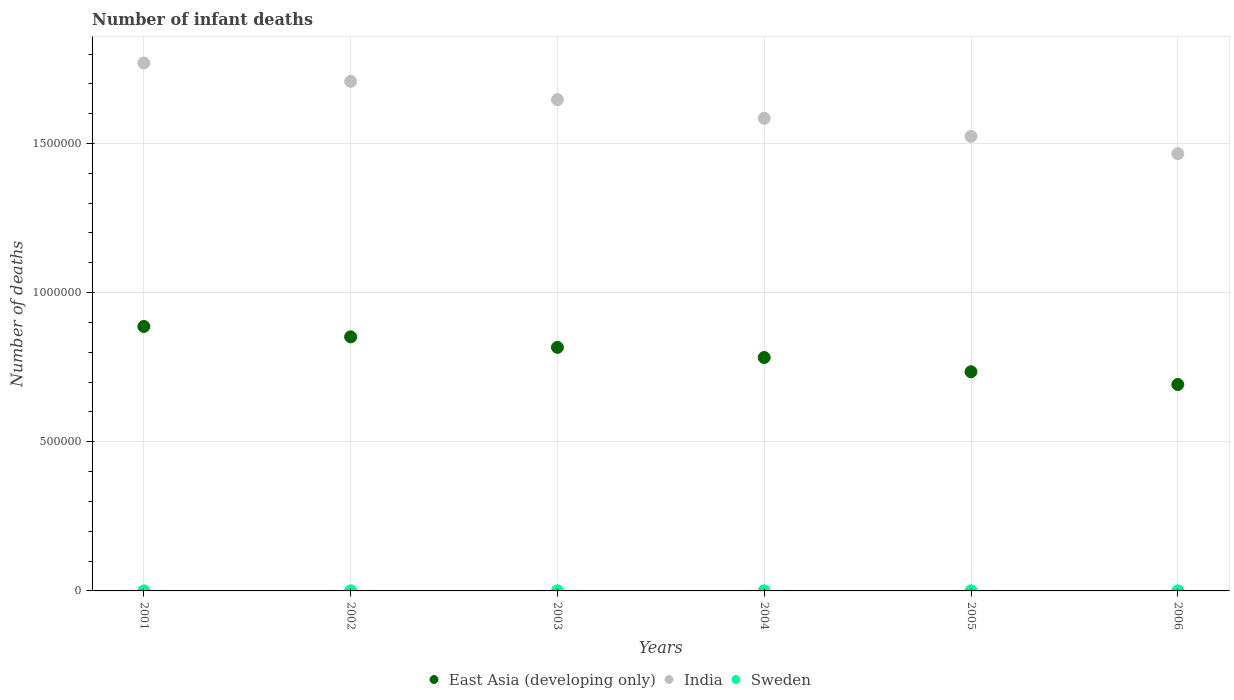How many different coloured dotlines are there?
Make the answer very short. 3. Is the number of dotlines equal to the number of legend labels?
Provide a short and direct response. Yes. What is the number of infant deaths in Sweden in 2005?
Your response must be concise. 351. Across all years, what is the maximum number of infant deaths in India?
Make the answer very short. 1.77e+06. Across all years, what is the minimum number of infant deaths in India?
Offer a terse response. 1.47e+06. In which year was the number of infant deaths in East Asia (developing only) maximum?
Your response must be concise. 2001. In which year was the number of infant deaths in Sweden minimum?
Your answer should be very brief. 2001. What is the total number of infant deaths in Sweden in the graph?
Make the answer very short. 1871. What is the difference between the number of infant deaths in Sweden in 2001 and that in 2004?
Keep it short and to the point. -83. What is the difference between the number of infant deaths in Sweden in 2005 and the number of infant deaths in East Asia (developing only) in 2001?
Your answer should be compact. -8.86e+05. What is the average number of infant deaths in East Asia (developing only) per year?
Your response must be concise. 7.94e+05. In the year 2003, what is the difference between the number of infant deaths in Sweden and number of infant deaths in East Asia (developing only)?
Keep it short and to the point. -8.16e+05. In how many years, is the number of infant deaths in India greater than 700000?
Ensure brevity in your answer.  6. What is the ratio of the number of infant deaths in Sweden in 2003 to that in 2005?
Your response must be concise. 0.89. Is the number of infant deaths in Sweden in 2002 less than that in 2006?
Give a very brief answer. Yes. What is the difference between the highest and the second highest number of infant deaths in Sweden?
Your answer should be very brief. 13. What is the difference between the highest and the lowest number of infant deaths in India?
Give a very brief answer. 3.04e+05. Is the sum of the number of infant deaths in India in 2003 and 2006 greater than the maximum number of infant deaths in Sweden across all years?
Your answer should be very brief. Yes. Does the number of infant deaths in Sweden monotonically increase over the years?
Your answer should be very brief. No. How many dotlines are there?
Provide a short and direct response. 3. Are the values on the major ticks of Y-axis written in scientific E-notation?
Make the answer very short. No. Does the graph contain any zero values?
Provide a succinct answer. No. Does the graph contain grids?
Your answer should be compact. Yes. How many legend labels are there?
Ensure brevity in your answer.  3. How are the legend labels stacked?
Your response must be concise. Horizontal. What is the title of the graph?
Provide a short and direct response. Number of infant deaths. Does "Comoros" appear as one of the legend labels in the graph?
Provide a short and direct response. No. What is the label or title of the Y-axis?
Provide a succinct answer. Number of deaths. What is the Number of deaths of East Asia (developing only) in 2001?
Your answer should be compact. 8.87e+05. What is the Number of deaths in India in 2001?
Your answer should be very brief. 1.77e+06. What is the Number of deaths of Sweden in 2001?
Your response must be concise. 255. What is the Number of deaths in East Asia (developing only) in 2002?
Provide a short and direct response. 8.52e+05. What is the Number of deaths of India in 2002?
Offer a terse response. 1.71e+06. What is the Number of deaths of Sweden in 2002?
Offer a very short reply. 280. What is the Number of deaths in East Asia (developing only) in 2003?
Keep it short and to the point. 8.16e+05. What is the Number of deaths of India in 2003?
Provide a short and direct response. 1.65e+06. What is the Number of deaths in Sweden in 2003?
Your answer should be compact. 311. What is the Number of deaths in East Asia (developing only) in 2004?
Make the answer very short. 7.83e+05. What is the Number of deaths in India in 2004?
Offer a terse response. 1.58e+06. What is the Number of deaths of Sweden in 2004?
Your answer should be very brief. 338. What is the Number of deaths in East Asia (developing only) in 2005?
Ensure brevity in your answer.  7.35e+05. What is the Number of deaths of India in 2005?
Your response must be concise. 1.52e+06. What is the Number of deaths in Sweden in 2005?
Provide a succinct answer. 351. What is the Number of deaths of East Asia (developing only) in 2006?
Your answer should be compact. 6.92e+05. What is the Number of deaths in India in 2006?
Ensure brevity in your answer.  1.47e+06. What is the Number of deaths in Sweden in 2006?
Keep it short and to the point. 336. Across all years, what is the maximum Number of deaths of East Asia (developing only)?
Your answer should be very brief. 8.87e+05. Across all years, what is the maximum Number of deaths of India?
Provide a succinct answer. 1.77e+06. Across all years, what is the maximum Number of deaths in Sweden?
Your answer should be compact. 351. Across all years, what is the minimum Number of deaths of East Asia (developing only)?
Provide a short and direct response. 6.92e+05. Across all years, what is the minimum Number of deaths of India?
Your response must be concise. 1.47e+06. Across all years, what is the minimum Number of deaths in Sweden?
Provide a succinct answer. 255. What is the total Number of deaths of East Asia (developing only) in the graph?
Keep it short and to the point. 4.76e+06. What is the total Number of deaths of India in the graph?
Make the answer very short. 9.70e+06. What is the total Number of deaths of Sweden in the graph?
Make the answer very short. 1871. What is the difference between the Number of deaths of East Asia (developing only) in 2001 and that in 2002?
Provide a short and direct response. 3.48e+04. What is the difference between the Number of deaths of India in 2001 and that in 2002?
Make the answer very short. 6.18e+04. What is the difference between the Number of deaths in Sweden in 2001 and that in 2002?
Provide a succinct answer. -25. What is the difference between the Number of deaths of East Asia (developing only) in 2001 and that in 2003?
Your response must be concise. 7.01e+04. What is the difference between the Number of deaths of India in 2001 and that in 2003?
Your answer should be very brief. 1.23e+05. What is the difference between the Number of deaths in Sweden in 2001 and that in 2003?
Make the answer very short. -56. What is the difference between the Number of deaths in East Asia (developing only) in 2001 and that in 2004?
Offer a very short reply. 1.04e+05. What is the difference between the Number of deaths of India in 2001 and that in 2004?
Your answer should be compact. 1.86e+05. What is the difference between the Number of deaths of Sweden in 2001 and that in 2004?
Your answer should be very brief. -83. What is the difference between the Number of deaths in East Asia (developing only) in 2001 and that in 2005?
Provide a short and direct response. 1.52e+05. What is the difference between the Number of deaths of India in 2001 and that in 2005?
Ensure brevity in your answer.  2.46e+05. What is the difference between the Number of deaths in Sweden in 2001 and that in 2005?
Your answer should be compact. -96. What is the difference between the Number of deaths in East Asia (developing only) in 2001 and that in 2006?
Offer a very short reply. 1.95e+05. What is the difference between the Number of deaths in India in 2001 and that in 2006?
Your answer should be compact. 3.04e+05. What is the difference between the Number of deaths of Sweden in 2001 and that in 2006?
Provide a short and direct response. -81. What is the difference between the Number of deaths of East Asia (developing only) in 2002 and that in 2003?
Provide a short and direct response. 3.53e+04. What is the difference between the Number of deaths in India in 2002 and that in 2003?
Provide a succinct answer. 6.11e+04. What is the difference between the Number of deaths in Sweden in 2002 and that in 2003?
Offer a very short reply. -31. What is the difference between the Number of deaths in East Asia (developing only) in 2002 and that in 2004?
Provide a short and direct response. 6.93e+04. What is the difference between the Number of deaths of India in 2002 and that in 2004?
Ensure brevity in your answer.  1.24e+05. What is the difference between the Number of deaths in Sweden in 2002 and that in 2004?
Provide a short and direct response. -58. What is the difference between the Number of deaths in East Asia (developing only) in 2002 and that in 2005?
Your answer should be compact. 1.17e+05. What is the difference between the Number of deaths of India in 2002 and that in 2005?
Your answer should be compact. 1.84e+05. What is the difference between the Number of deaths in Sweden in 2002 and that in 2005?
Offer a terse response. -71. What is the difference between the Number of deaths in East Asia (developing only) in 2002 and that in 2006?
Your answer should be very brief. 1.60e+05. What is the difference between the Number of deaths of India in 2002 and that in 2006?
Provide a short and direct response. 2.42e+05. What is the difference between the Number of deaths of Sweden in 2002 and that in 2006?
Make the answer very short. -56. What is the difference between the Number of deaths of East Asia (developing only) in 2003 and that in 2004?
Your answer should be very brief. 3.40e+04. What is the difference between the Number of deaths of India in 2003 and that in 2004?
Provide a succinct answer. 6.26e+04. What is the difference between the Number of deaths of Sweden in 2003 and that in 2004?
Make the answer very short. -27. What is the difference between the Number of deaths in East Asia (developing only) in 2003 and that in 2005?
Your answer should be very brief. 8.17e+04. What is the difference between the Number of deaths of India in 2003 and that in 2005?
Keep it short and to the point. 1.23e+05. What is the difference between the Number of deaths of Sweden in 2003 and that in 2005?
Make the answer very short. -40. What is the difference between the Number of deaths of East Asia (developing only) in 2003 and that in 2006?
Your answer should be very brief. 1.24e+05. What is the difference between the Number of deaths of India in 2003 and that in 2006?
Your response must be concise. 1.81e+05. What is the difference between the Number of deaths in East Asia (developing only) in 2004 and that in 2005?
Keep it short and to the point. 4.77e+04. What is the difference between the Number of deaths of India in 2004 and that in 2005?
Your response must be concise. 6.06e+04. What is the difference between the Number of deaths of Sweden in 2004 and that in 2005?
Give a very brief answer. -13. What is the difference between the Number of deaths in East Asia (developing only) in 2004 and that in 2006?
Your answer should be compact. 9.05e+04. What is the difference between the Number of deaths of India in 2004 and that in 2006?
Your response must be concise. 1.19e+05. What is the difference between the Number of deaths of Sweden in 2004 and that in 2006?
Your answer should be compact. 2. What is the difference between the Number of deaths of East Asia (developing only) in 2005 and that in 2006?
Your answer should be compact. 4.28e+04. What is the difference between the Number of deaths of India in 2005 and that in 2006?
Your response must be concise. 5.80e+04. What is the difference between the Number of deaths in Sweden in 2005 and that in 2006?
Ensure brevity in your answer.  15. What is the difference between the Number of deaths in East Asia (developing only) in 2001 and the Number of deaths in India in 2002?
Keep it short and to the point. -8.22e+05. What is the difference between the Number of deaths of East Asia (developing only) in 2001 and the Number of deaths of Sweden in 2002?
Ensure brevity in your answer.  8.86e+05. What is the difference between the Number of deaths in India in 2001 and the Number of deaths in Sweden in 2002?
Offer a terse response. 1.77e+06. What is the difference between the Number of deaths in East Asia (developing only) in 2001 and the Number of deaths in India in 2003?
Keep it short and to the point. -7.60e+05. What is the difference between the Number of deaths of East Asia (developing only) in 2001 and the Number of deaths of Sweden in 2003?
Offer a very short reply. 8.86e+05. What is the difference between the Number of deaths of India in 2001 and the Number of deaths of Sweden in 2003?
Offer a very short reply. 1.77e+06. What is the difference between the Number of deaths in East Asia (developing only) in 2001 and the Number of deaths in India in 2004?
Your answer should be very brief. -6.98e+05. What is the difference between the Number of deaths in East Asia (developing only) in 2001 and the Number of deaths in Sweden in 2004?
Offer a very short reply. 8.86e+05. What is the difference between the Number of deaths in India in 2001 and the Number of deaths in Sweden in 2004?
Your answer should be compact. 1.77e+06. What is the difference between the Number of deaths of East Asia (developing only) in 2001 and the Number of deaths of India in 2005?
Your answer should be very brief. -6.37e+05. What is the difference between the Number of deaths in East Asia (developing only) in 2001 and the Number of deaths in Sweden in 2005?
Your response must be concise. 8.86e+05. What is the difference between the Number of deaths in India in 2001 and the Number of deaths in Sweden in 2005?
Make the answer very short. 1.77e+06. What is the difference between the Number of deaths of East Asia (developing only) in 2001 and the Number of deaths of India in 2006?
Provide a short and direct response. -5.79e+05. What is the difference between the Number of deaths of East Asia (developing only) in 2001 and the Number of deaths of Sweden in 2006?
Provide a succinct answer. 8.86e+05. What is the difference between the Number of deaths in India in 2001 and the Number of deaths in Sweden in 2006?
Provide a short and direct response. 1.77e+06. What is the difference between the Number of deaths in East Asia (developing only) in 2002 and the Number of deaths in India in 2003?
Your answer should be compact. -7.95e+05. What is the difference between the Number of deaths of East Asia (developing only) in 2002 and the Number of deaths of Sweden in 2003?
Make the answer very short. 8.51e+05. What is the difference between the Number of deaths in India in 2002 and the Number of deaths in Sweden in 2003?
Make the answer very short. 1.71e+06. What is the difference between the Number of deaths of East Asia (developing only) in 2002 and the Number of deaths of India in 2004?
Your answer should be very brief. -7.33e+05. What is the difference between the Number of deaths in East Asia (developing only) in 2002 and the Number of deaths in Sweden in 2004?
Keep it short and to the point. 8.51e+05. What is the difference between the Number of deaths of India in 2002 and the Number of deaths of Sweden in 2004?
Your response must be concise. 1.71e+06. What is the difference between the Number of deaths of East Asia (developing only) in 2002 and the Number of deaths of India in 2005?
Provide a short and direct response. -6.72e+05. What is the difference between the Number of deaths in East Asia (developing only) in 2002 and the Number of deaths in Sweden in 2005?
Keep it short and to the point. 8.51e+05. What is the difference between the Number of deaths in India in 2002 and the Number of deaths in Sweden in 2005?
Provide a succinct answer. 1.71e+06. What is the difference between the Number of deaths in East Asia (developing only) in 2002 and the Number of deaths in India in 2006?
Make the answer very short. -6.14e+05. What is the difference between the Number of deaths in East Asia (developing only) in 2002 and the Number of deaths in Sweden in 2006?
Your response must be concise. 8.51e+05. What is the difference between the Number of deaths in India in 2002 and the Number of deaths in Sweden in 2006?
Offer a terse response. 1.71e+06. What is the difference between the Number of deaths of East Asia (developing only) in 2003 and the Number of deaths of India in 2004?
Make the answer very short. -7.68e+05. What is the difference between the Number of deaths in East Asia (developing only) in 2003 and the Number of deaths in Sweden in 2004?
Provide a succinct answer. 8.16e+05. What is the difference between the Number of deaths in India in 2003 and the Number of deaths in Sweden in 2004?
Offer a terse response. 1.65e+06. What is the difference between the Number of deaths of East Asia (developing only) in 2003 and the Number of deaths of India in 2005?
Provide a succinct answer. -7.07e+05. What is the difference between the Number of deaths of East Asia (developing only) in 2003 and the Number of deaths of Sweden in 2005?
Make the answer very short. 8.16e+05. What is the difference between the Number of deaths in India in 2003 and the Number of deaths in Sweden in 2005?
Keep it short and to the point. 1.65e+06. What is the difference between the Number of deaths in East Asia (developing only) in 2003 and the Number of deaths in India in 2006?
Offer a terse response. -6.49e+05. What is the difference between the Number of deaths in East Asia (developing only) in 2003 and the Number of deaths in Sweden in 2006?
Keep it short and to the point. 8.16e+05. What is the difference between the Number of deaths in India in 2003 and the Number of deaths in Sweden in 2006?
Your response must be concise. 1.65e+06. What is the difference between the Number of deaths in East Asia (developing only) in 2004 and the Number of deaths in India in 2005?
Offer a very short reply. -7.41e+05. What is the difference between the Number of deaths in East Asia (developing only) in 2004 and the Number of deaths in Sweden in 2005?
Offer a very short reply. 7.82e+05. What is the difference between the Number of deaths of India in 2004 and the Number of deaths of Sweden in 2005?
Provide a succinct answer. 1.58e+06. What is the difference between the Number of deaths in East Asia (developing only) in 2004 and the Number of deaths in India in 2006?
Provide a succinct answer. -6.83e+05. What is the difference between the Number of deaths of East Asia (developing only) in 2004 and the Number of deaths of Sweden in 2006?
Offer a terse response. 7.82e+05. What is the difference between the Number of deaths in India in 2004 and the Number of deaths in Sweden in 2006?
Keep it short and to the point. 1.58e+06. What is the difference between the Number of deaths in East Asia (developing only) in 2005 and the Number of deaths in India in 2006?
Offer a terse response. -7.31e+05. What is the difference between the Number of deaths in East Asia (developing only) in 2005 and the Number of deaths in Sweden in 2006?
Make the answer very short. 7.34e+05. What is the difference between the Number of deaths in India in 2005 and the Number of deaths in Sweden in 2006?
Your answer should be compact. 1.52e+06. What is the average Number of deaths in East Asia (developing only) per year?
Make the answer very short. 7.94e+05. What is the average Number of deaths in India per year?
Give a very brief answer. 1.62e+06. What is the average Number of deaths of Sweden per year?
Provide a short and direct response. 311.83. In the year 2001, what is the difference between the Number of deaths of East Asia (developing only) and Number of deaths of India?
Your response must be concise. -8.83e+05. In the year 2001, what is the difference between the Number of deaths of East Asia (developing only) and Number of deaths of Sweden?
Provide a short and direct response. 8.86e+05. In the year 2001, what is the difference between the Number of deaths in India and Number of deaths in Sweden?
Offer a terse response. 1.77e+06. In the year 2002, what is the difference between the Number of deaths of East Asia (developing only) and Number of deaths of India?
Provide a short and direct response. -8.56e+05. In the year 2002, what is the difference between the Number of deaths of East Asia (developing only) and Number of deaths of Sweden?
Ensure brevity in your answer.  8.51e+05. In the year 2002, what is the difference between the Number of deaths of India and Number of deaths of Sweden?
Provide a short and direct response. 1.71e+06. In the year 2003, what is the difference between the Number of deaths in East Asia (developing only) and Number of deaths in India?
Provide a succinct answer. -8.31e+05. In the year 2003, what is the difference between the Number of deaths of East Asia (developing only) and Number of deaths of Sweden?
Your answer should be very brief. 8.16e+05. In the year 2003, what is the difference between the Number of deaths in India and Number of deaths in Sweden?
Offer a terse response. 1.65e+06. In the year 2004, what is the difference between the Number of deaths of East Asia (developing only) and Number of deaths of India?
Offer a very short reply. -8.02e+05. In the year 2004, what is the difference between the Number of deaths in East Asia (developing only) and Number of deaths in Sweden?
Ensure brevity in your answer.  7.82e+05. In the year 2004, what is the difference between the Number of deaths in India and Number of deaths in Sweden?
Your answer should be compact. 1.58e+06. In the year 2005, what is the difference between the Number of deaths of East Asia (developing only) and Number of deaths of India?
Your answer should be compact. -7.89e+05. In the year 2005, what is the difference between the Number of deaths in East Asia (developing only) and Number of deaths in Sweden?
Provide a succinct answer. 7.34e+05. In the year 2005, what is the difference between the Number of deaths in India and Number of deaths in Sweden?
Offer a very short reply. 1.52e+06. In the year 2006, what is the difference between the Number of deaths in East Asia (developing only) and Number of deaths in India?
Your answer should be compact. -7.74e+05. In the year 2006, what is the difference between the Number of deaths of East Asia (developing only) and Number of deaths of Sweden?
Keep it short and to the point. 6.92e+05. In the year 2006, what is the difference between the Number of deaths in India and Number of deaths in Sweden?
Your answer should be very brief. 1.47e+06. What is the ratio of the Number of deaths in East Asia (developing only) in 2001 to that in 2002?
Offer a terse response. 1.04. What is the ratio of the Number of deaths in India in 2001 to that in 2002?
Provide a succinct answer. 1.04. What is the ratio of the Number of deaths in Sweden in 2001 to that in 2002?
Your answer should be compact. 0.91. What is the ratio of the Number of deaths in East Asia (developing only) in 2001 to that in 2003?
Your response must be concise. 1.09. What is the ratio of the Number of deaths of India in 2001 to that in 2003?
Offer a very short reply. 1.07. What is the ratio of the Number of deaths of Sweden in 2001 to that in 2003?
Make the answer very short. 0.82. What is the ratio of the Number of deaths of East Asia (developing only) in 2001 to that in 2004?
Ensure brevity in your answer.  1.13. What is the ratio of the Number of deaths of India in 2001 to that in 2004?
Keep it short and to the point. 1.12. What is the ratio of the Number of deaths of Sweden in 2001 to that in 2004?
Provide a succinct answer. 0.75. What is the ratio of the Number of deaths in East Asia (developing only) in 2001 to that in 2005?
Your answer should be very brief. 1.21. What is the ratio of the Number of deaths in India in 2001 to that in 2005?
Your response must be concise. 1.16. What is the ratio of the Number of deaths in Sweden in 2001 to that in 2005?
Your answer should be very brief. 0.73. What is the ratio of the Number of deaths of East Asia (developing only) in 2001 to that in 2006?
Your answer should be compact. 1.28. What is the ratio of the Number of deaths of India in 2001 to that in 2006?
Ensure brevity in your answer.  1.21. What is the ratio of the Number of deaths of Sweden in 2001 to that in 2006?
Your answer should be compact. 0.76. What is the ratio of the Number of deaths in East Asia (developing only) in 2002 to that in 2003?
Your answer should be compact. 1.04. What is the ratio of the Number of deaths of India in 2002 to that in 2003?
Offer a very short reply. 1.04. What is the ratio of the Number of deaths of Sweden in 2002 to that in 2003?
Give a very brief answer. 0.9. What is the ratio of the Number of deaths of East Asia (developing only) in 2002 to that in 2004?
Your answer should be compact. 1.09. What is the ratio of the Number of deaths in India in 2002 to that in 2004?
Give a very brief answer. 1.08. What is the ratio of the Number of deaths of Sweden in 2002 to that in 2004?
Offer a very short reply. 0.83. What is the ratio of the Number of deaths in East Asia (developing only) in 2002 to that in 2005?
Ensure brevity in your answer.  1.16. What is the ratio of the Number of deaths in India in 2002 to that in 2005?
Ensure brevity in your answer.  1.12. What is the ratio of the Number of deaths of Sweden in 2002 to that in 2005?
Give a very brief answer. 0.8. What is the ratio of the Number of deaths in East Asia (developing only) in 2002 to that in 2006?
Your answer should be compact. 1.23. What is the ratio of the Number of deaths in India in 2002 to that in 2006?
Ensure brevity in your answer.  1.17. What is the ratio of the Number of deaths in East Asia (developing only) in 2003 to that in 2004?
Provide a short and direct response. 1.04. What is the ratio of the Number of deaths of India in 2003 to that in 2004?
Your response must be concise. 1.04. What is the ratio of the Number of deaths in Sweden in 2003 to that in 2004?
Offer a terse response. 0.92. What is the ratio of the Number of deaths of East Asia (developing only) in 2003 to that in 2005?
Your answer should be compact. 1.11. What is the ratio of the Number of deaths of India in 2003 to that in 2005?
Provide a succinct answer. 1.08. What is the ratio of the Number of deaths of Sweden in 2003 to that in 2005?
Offer a very short reply. 0.89. What is the ratio of the Number of deaths of East Asia (developing only) in 2003 to that in 2006?
Offer a terse response. 1.18. What is the ratio of the Number of deaths of India in 2003 to that in 2006?
Provide a short and direct response. 1.12. What is the ratio of the Number of deaths of Sweden in 2003 to that in 2006?
Your response must be concise. 0.93. What is the ratio of the Number of deaths in East Asia (developing only) in 2004 to that in 2005?
Make the answer very short. 1.06. What is the ratio of the Number of deaths in India in 2004 to that in 2005?
Offer a terse response. 1.04. What is the ratio of the Number of deaths of East Asia (developing only) in 2004 to that in 2006?
Offer a very short reply. 1.13. What is the ratio of the Number of deaths of India in 2004 to that in 2006?
Keep it short and to the point. 1.08. What is the ratio of the Number of deaths in East Asia (developing only) in 2005 to that in 2006?
Offer a terse response. 1.06. What is the ratio of the Number of deaths in India in 2005 to that in 2006?
Your response must be concise. 1.04. What is the ratio of the Number of deaths in Sweden in 2005 to that in 2006?
Make the answer very short. 1.04. What is the difference between the highest and the second highest Number of deaths in East Asia (developing only)?
Ensure brevity in your answer.  3.48e+04. What is the difference between the highest and the second highest Number of deaths of India?
Keep it short and to the point. 6.18e+04. What is the difference between the highest and the lowest Number of deaths of East Asia (developing only)?
Make the answer very short. 1.95e+05. What is the difference between the highest and the lowest Number of deaths in India?
Make the answer very short. 3.04e+05. What is the difference between the highest and the lowest Number of deaths of Sweden?
Ensure brevity in your answer.  96. 